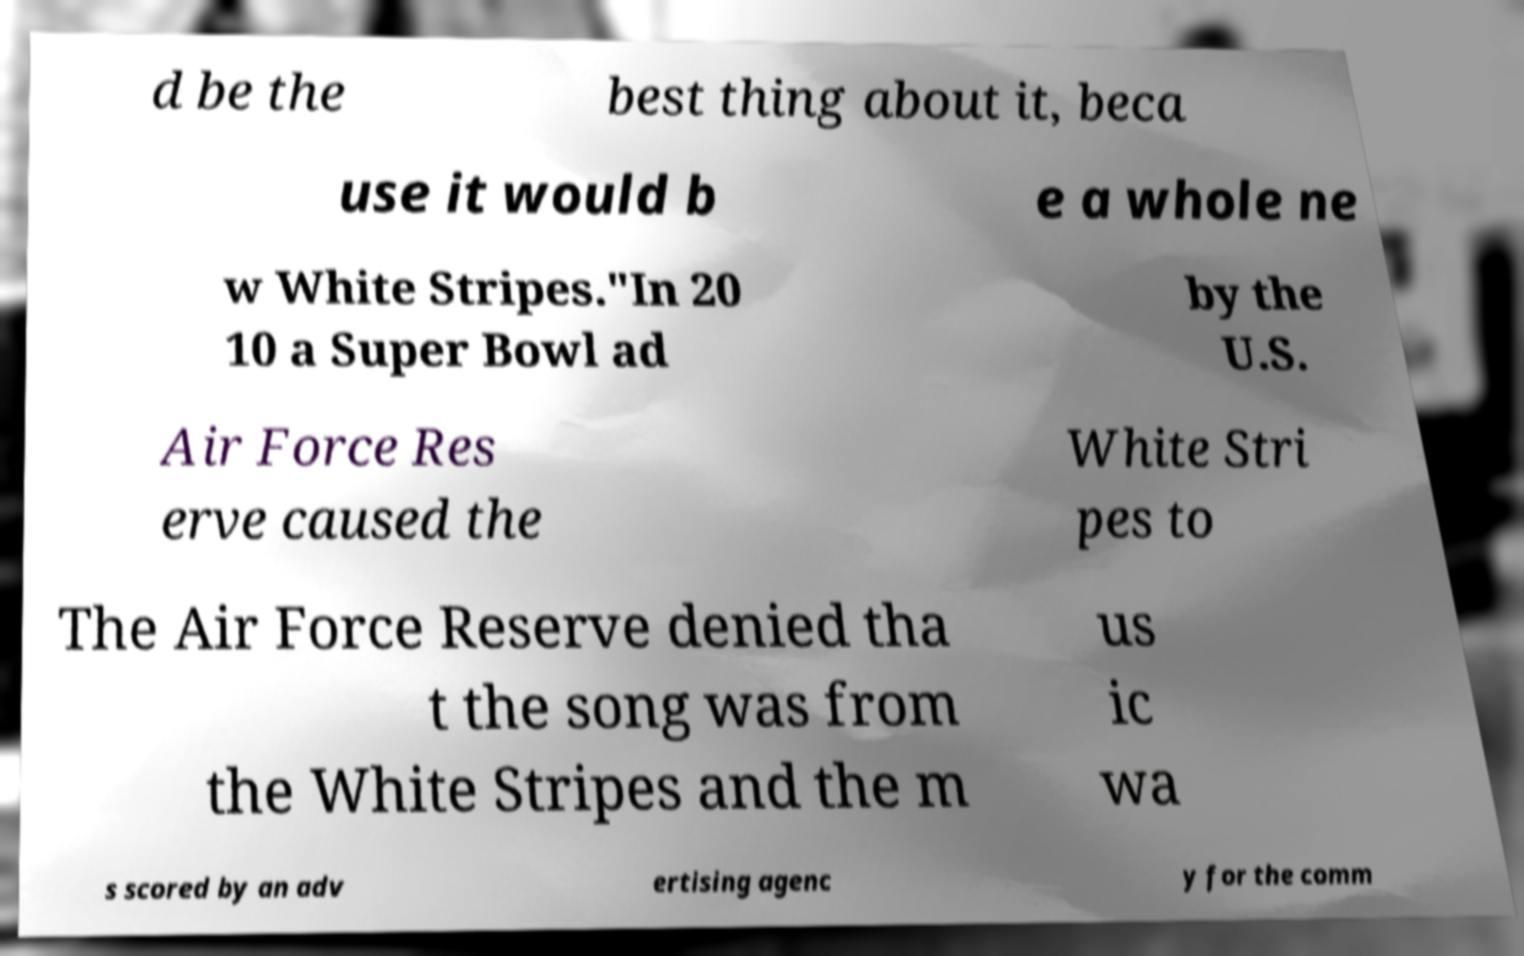Can you accurately transcribe the text from the provided image for me? d be the best thing about it, beca use it would b e a whole ne w White Stripes."In 20 10 a Super Bowl ad by the U.S. Air Force Res erve caused the White Stri pes to The Air Force Reserve denied tha t the song was from the White Stripes and the m us ic wa s scored by an adv ertising agenc y for the comm 